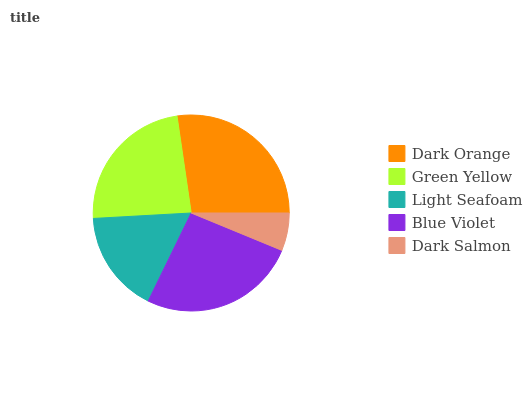Is Dark Salmon the minimum?
Answer yes or no. Yes. Is Dark Orange the maximum?
Answer yes or no. Yes. Is Green Yellow the minimum?
Answer yes or no. No. Is Green Yellow the maximum?
Answer yes or no. No. Is Dark Orange greater than Green Yellow?
Answer yes or no. Yes. Is Green Yellow less than Dark Orange?
Answer yes or no. Yes. Is Green Yellow greater than Dark Orange?
Answer yes or no. No. Is Dark Orange less than Green Yellow?
Answer yes or no. No. Is Green Yellow the high median?
Answer yes or no. Yes. Is Green Yellow the low median?
Answer yes or no. Yes. Is Light Seafoam the high median?
Answer yes or no. No. Is Dark Orange the low median?
Answer yes or no. No. 